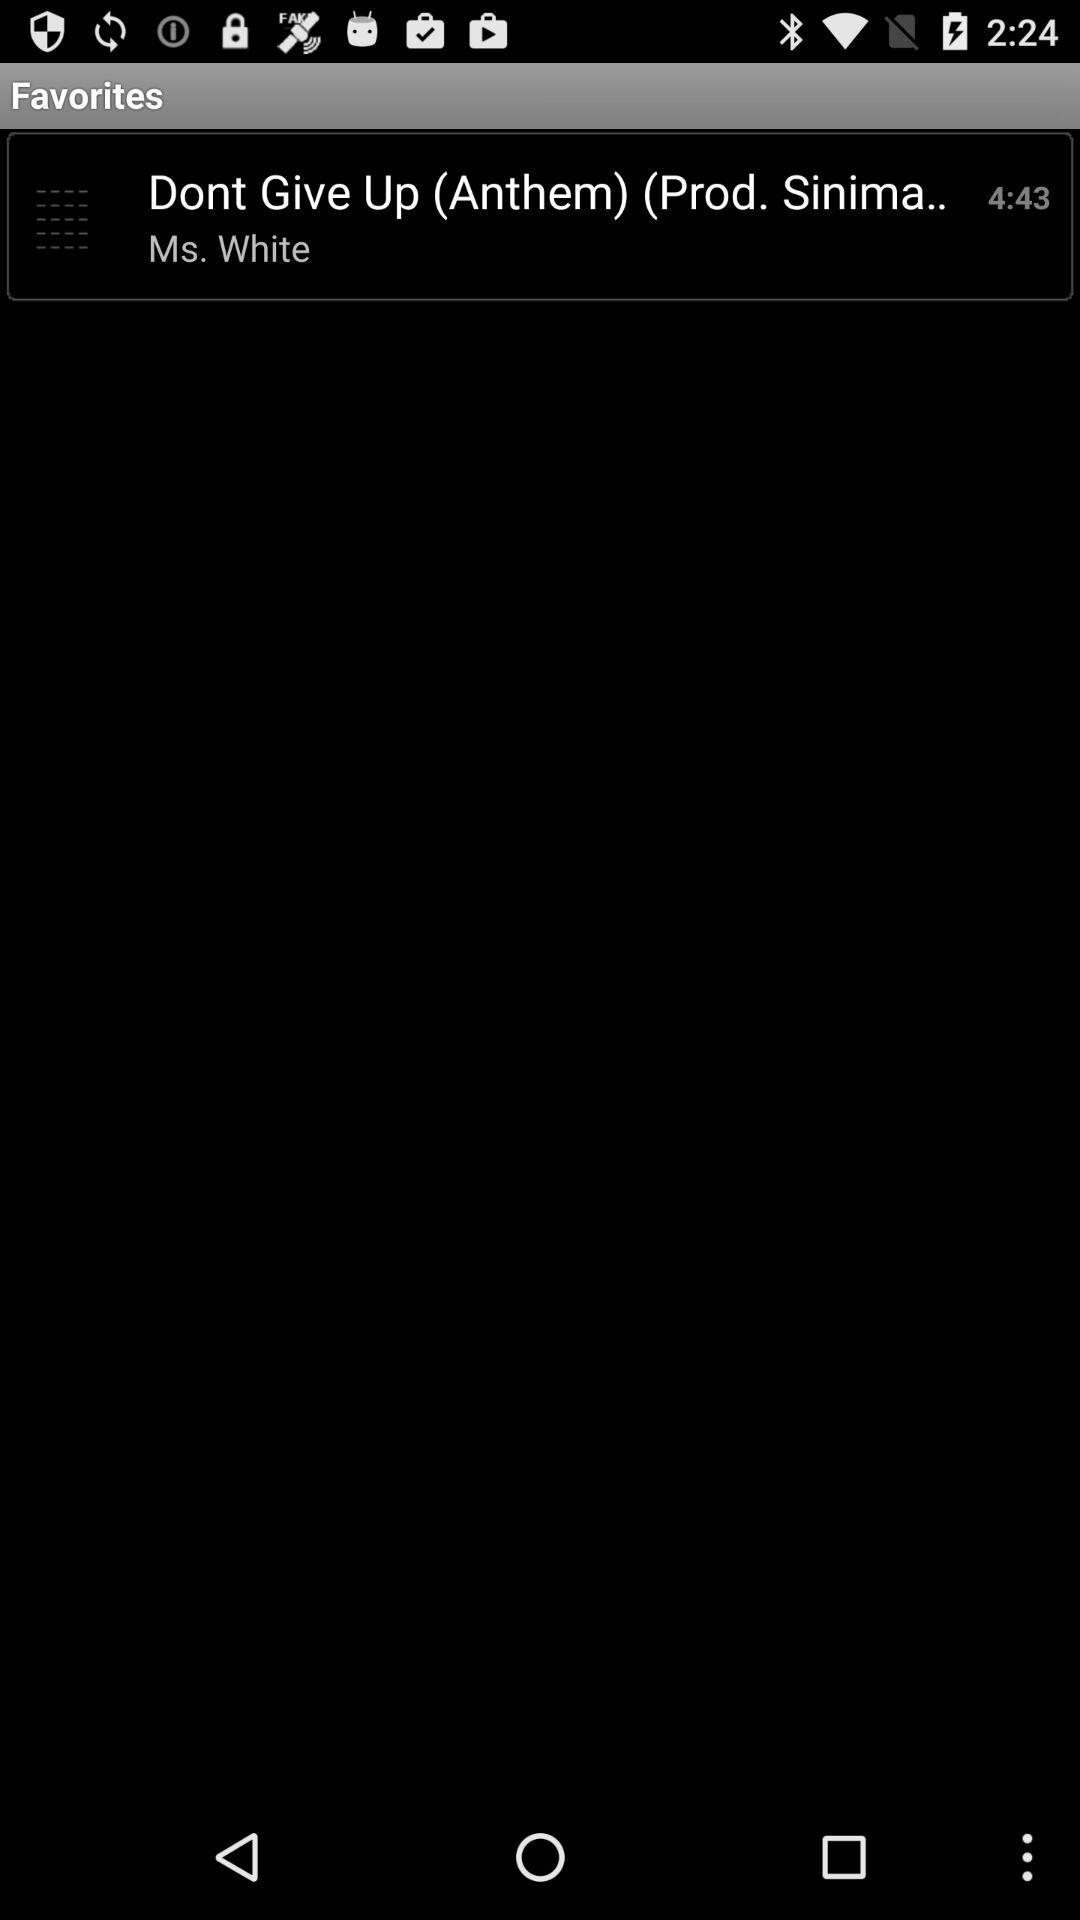What is the time duration of Anthem? The time duration is 4 minutes and 43 seconds. 